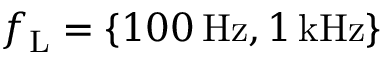Convert formula to latex. <formula><loc_0><loc_0><loc_500><loc_500>f _ { L } = \{ 1 0 0 \, H z , 1 \, k H z \}</formula> 